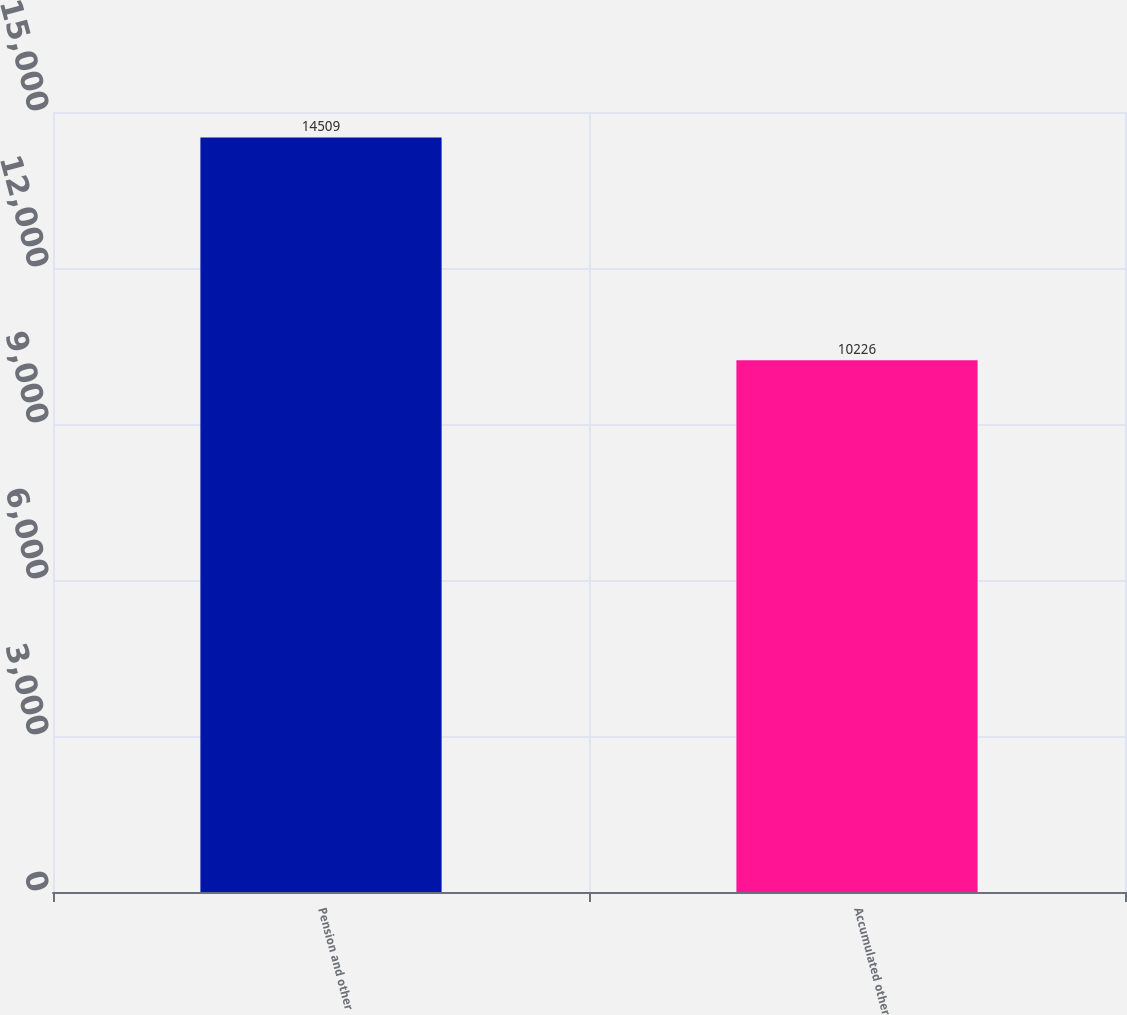Convert chart. <chart><loc_0><loc_0><loc_500><loc_500><bar_chart><fcel>Pension and other<fcel>Accumulated other<nl><fcel>14509<fcel>10226<nl></chart> 